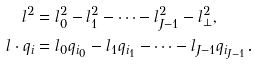<formula> <loc_0><loc_0><loc_500><loc_500>l ^ { 2 } & = l _ { 0 } ^ { 2 } - l _ { 1 } ^ { 2 } - \dots - l _ { J - 1 } ^ { 2 } - l _ { \perp } ^ { 2 } , \\ l \cdot q _ { i } & = l _ { 0 } q _ { i _ { 0 } } - l _ { 1 } q _ { i _ { 1 } } - \dots - l _ { J - 1 } q _ { i _ { J - 1 } } .</formula> 